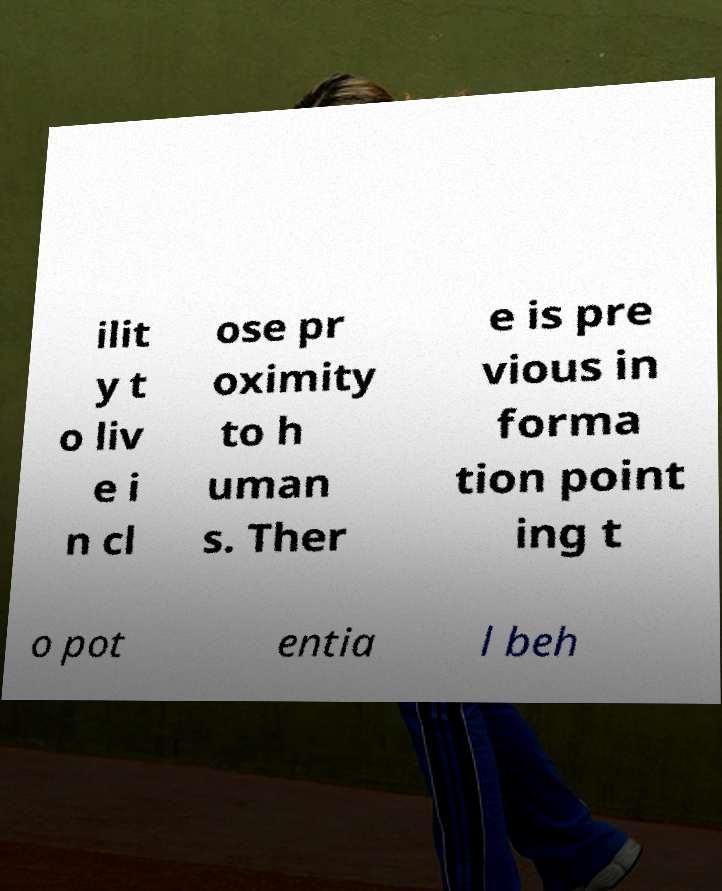What messages or text are displayed in this image? I need them in a readable, typed format. ilit y t o liv e i n cl ose pr oximity to h uman s. Ther e is pre vious in forma tion point ing t o pot entia l beh 